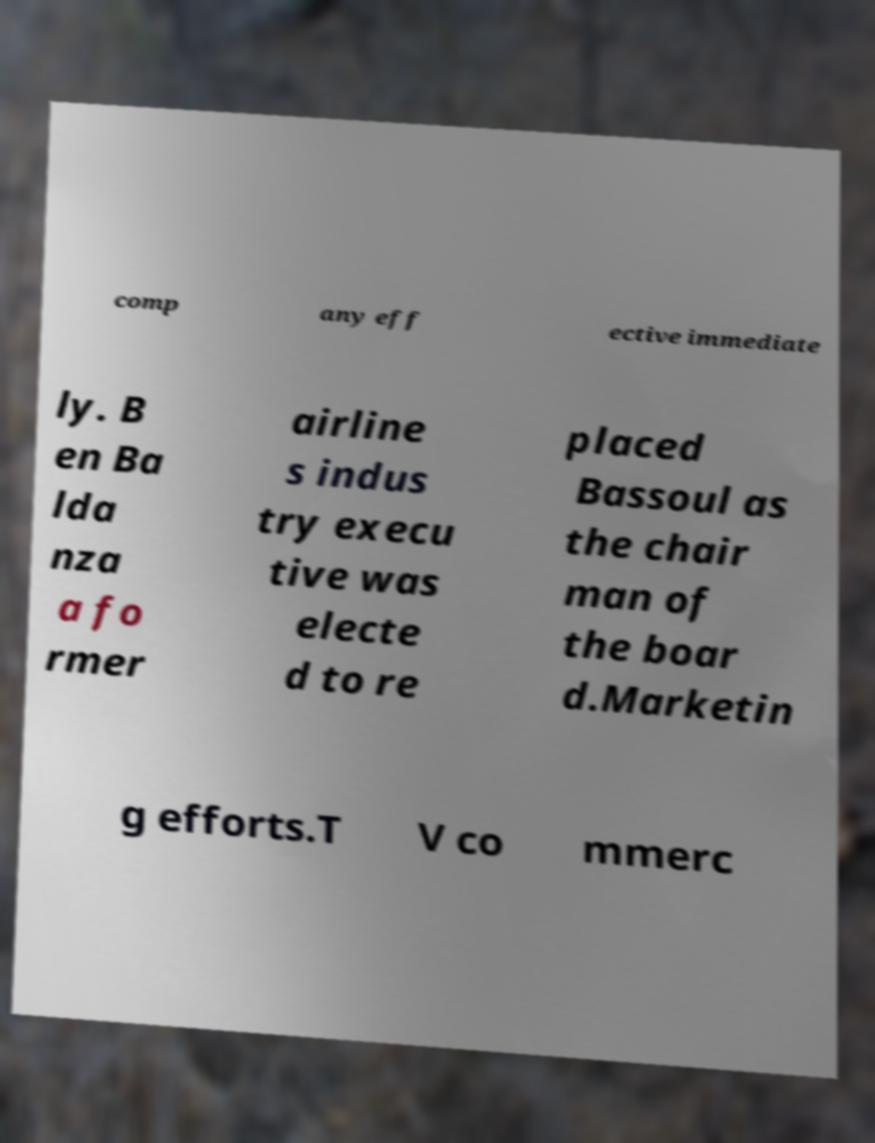Could you assist in decoding the text presented in this image and type it out clearly? comp any eff ective immediate ly. B en Ba lda nza a fo rmer airline s indus try execu tive was electe d to re placed Bassoul as the chair man of the boar d.Marketin g efforts.T V co mmerc 